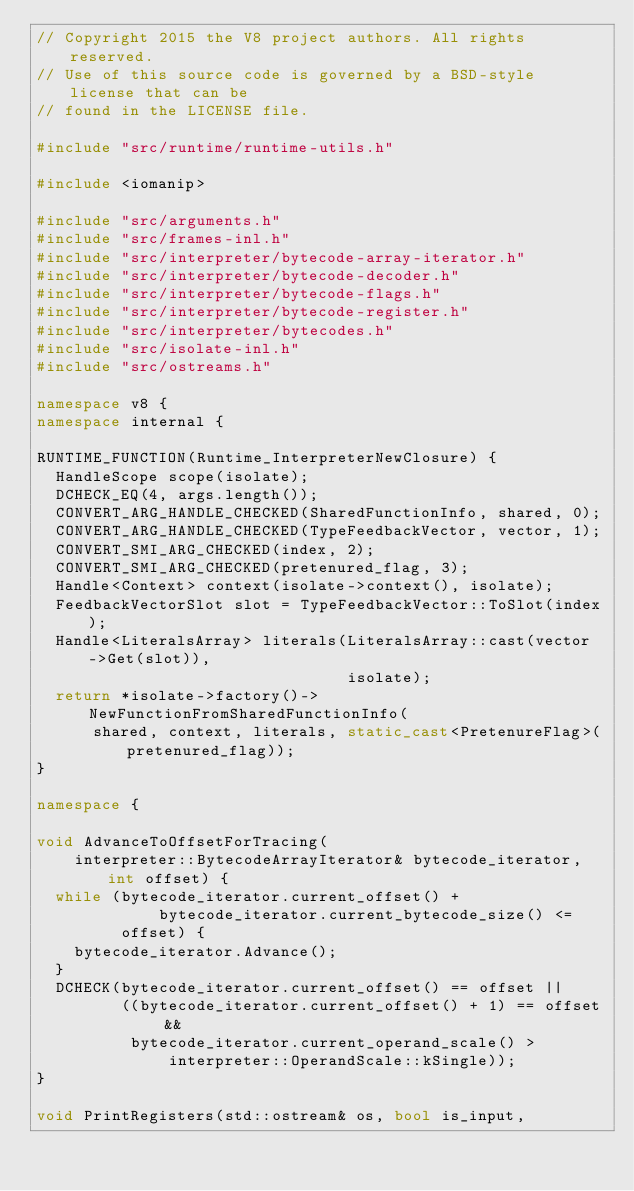Convert code to text. <code><loc_0><loc_0><loc_500><loc_500><_C++_>// Copyright 2015 the V8 project authors. All rights reserved.
// Use of this source code is governed by a BSD-style license that can be
// found in the LICENSE file.

#include "src/runtime/runtime-utils.h"

#include <iomanip>

#include "src/arguments.h"
#include "src/frames-inl.h"
#include "src/interpreter/bytecode-array-iterator.h"
#include "src/interpreter/bytecode-decoder.h"
#include "src/interpreter/bytecode-flags.h"
#include "src/interpreter/bytecode-register.h"
#include "src/interpreter/bytecodes.h"
#include "src/isolate-inl.h"
#include "src/ostreams.h"

namespace v8 {
namespace internal {

RUNTIME_FUNCTION(Runtime_InterpreterNewClosure) {
  HandleScope scope(isolate);
  DCHECK_EQ(4, args.length());
  CONVERT_ARG_HANDLE_CHECKED(SharedFunctionInfo, shared, 0);
  CONVERT_ARG_HANDLE_CHECKED(TypeFeedbackVector, vector, 1);
  CONVERT_SMI_ARG_CHECKED(index, 2);
  CONVERT_SMI_ARG_CHECKED(pretenured_flag, 3);
  Handle<Context> context(isolate->context(), isolate);
  FeedbackVectorSlot slot = TypeFeedbackVector::ToSlot(index);
  Handle<LiteralsArray> literals(LiteralsArray::cast(vector->Get(slot)),
                                 isolate);
  return *isolate->factory()->NewFunctionFromSharedFunctionInfo(
      shared, context, literals, static_cast<PretenureFlag>(pretenured_flag));
}

namespace {

void AdvanceToOffsetForTracing(
    interpreter::BytecodeArrayIterator& bytecode_iterator, int offset) {
  while (bytecode_iterator.current_offset() +
             bytecode_iterator.current_bytecode_size() <=
         offset) {
    bytecode_iterator.Advance();
  }
  DCHECK(bytecode_iterator.current_offset() == offset ||
         ((bytecode_iterator.current_offset() + 1) == offset &&
          bytecode_iterator.current_operand_scale() >
              interpreter::OperandScale::kSingle));
}

void PrintRegisters(std::ostream& os, bool is_input,</code> 